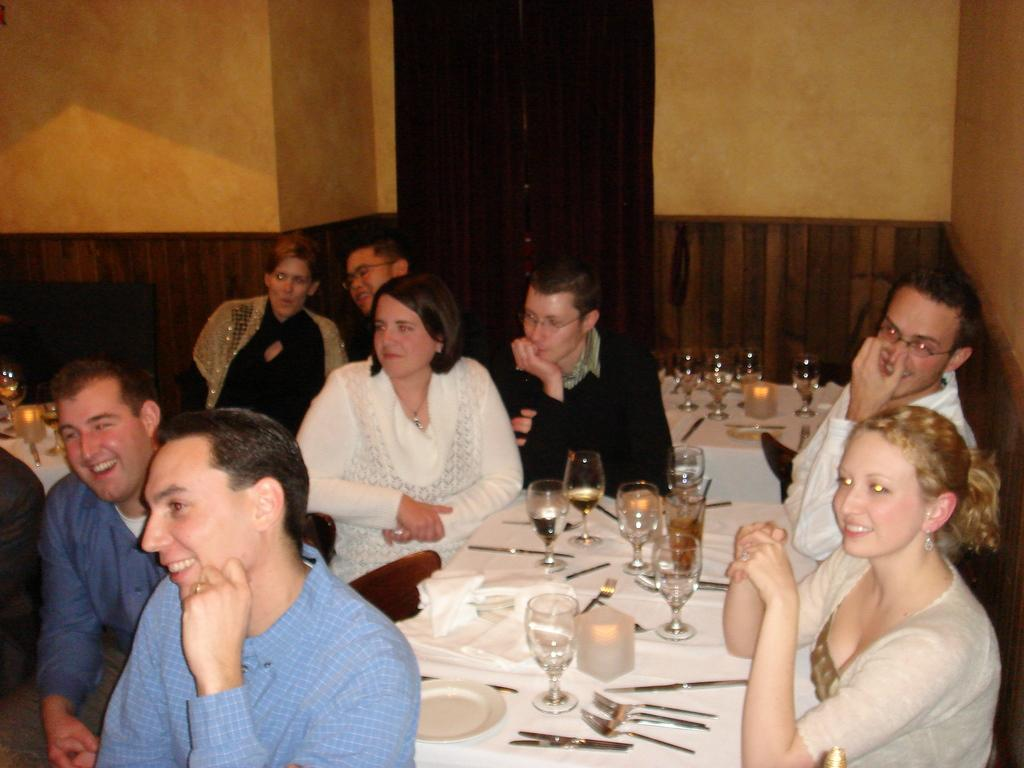How many persons are visible in the image? There are persons in the image, but the exact number is not specified. What is behind the persons in the image? The persons are in front of a wall. What type of furniture is present in the image? There are tables in the image. What items can be seen on the tables? Glasses, knives, and forks are present on the tables. What type of yam is being served on the tables in the image? There is no yam present in the image; only glasses, knives, and forks are visible on the tables. What color is the sweater worn by the person in the image? The facts provided do not mention any clothing or colors, so it is impossible to determine the color of any sweater in the image. 